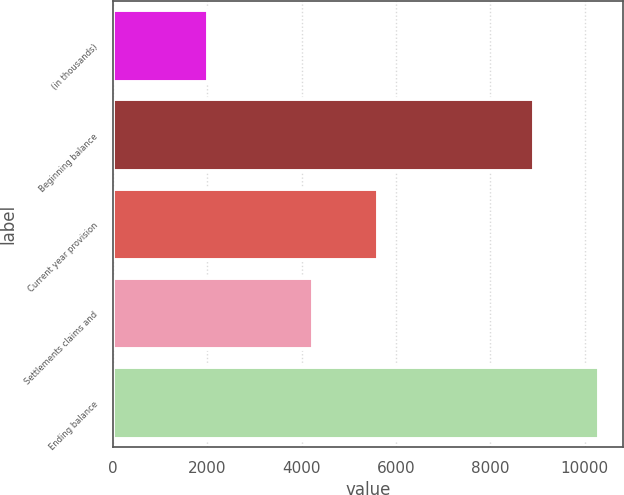Convert chart to OTSL. <chart><loc_0><loc_0><loc_500><loc_500><bar_chart><fcel>(in thousands)<fcel>Beginning balance<fcel>Current year provision<fcel>Settlements claims and<fcel>Ending balance<nl><fcel>2011<fcel>8925<fcel>5619<fcel>4244<fcel>10300<nl></chart> 